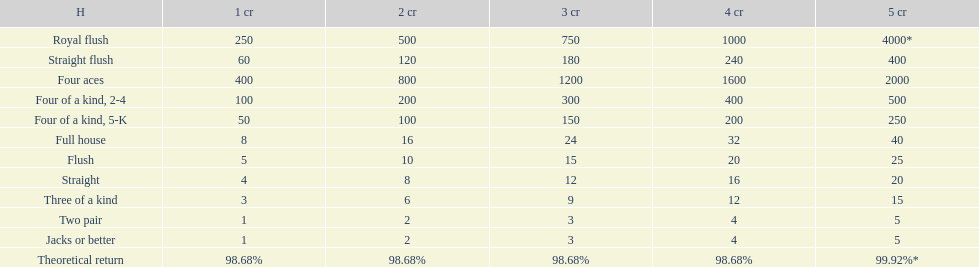Is a 2 credit full house the same as a 5 credit three of a kind? No. 